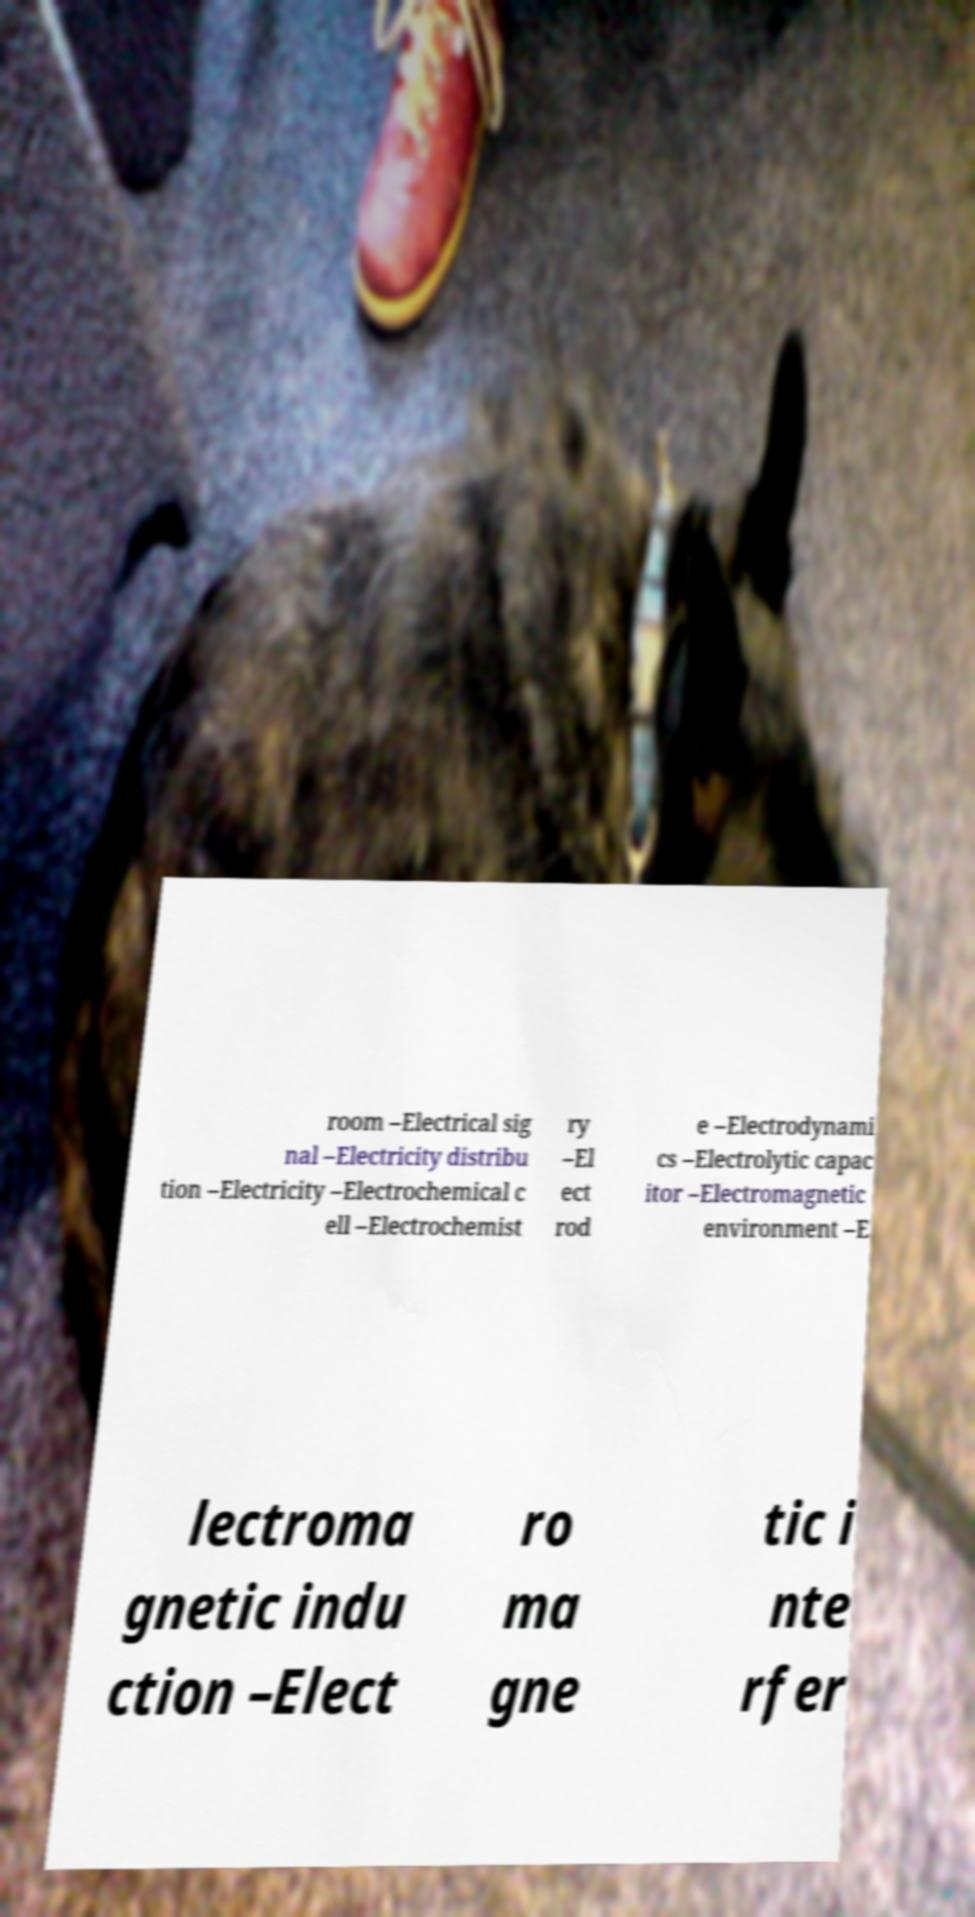What messages or text are displayed in this image? I need them in a readable, typed format. room –Electrical sig nal –Electricity distribu tion –Electricity –Electrochemical c ell –Electrochemist ry –El ect rod e –Electrodynami cs –Electrolytic capac itor –Electromagnetic environment –E lectroma gnetic indu ction –Elect ro ma gne tic i nte rfer 